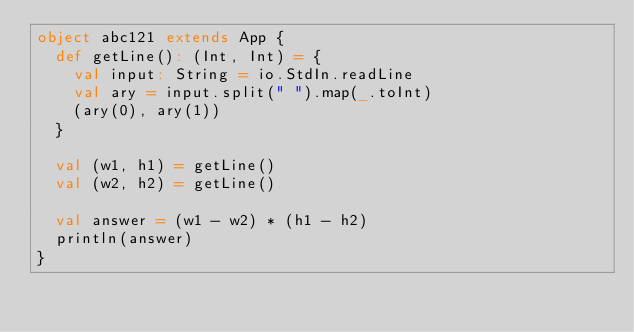<code> <loc_0><loc_0><loc_500><loc_500><_Scala_>object abc121 extends App {
  def getLine(): (Int, Int) = {
    val input: String = io.StdIn.readLine
    val ary = input.split(" ").map(_.toInt)
    (ary(0), ary(1))
  }

  val (w1, h1) = getLine()
  val (w2, h2) = getLine()

  val answer = (w1 - w2) * (h1 - h2)
  println(answer)
}
</code> 